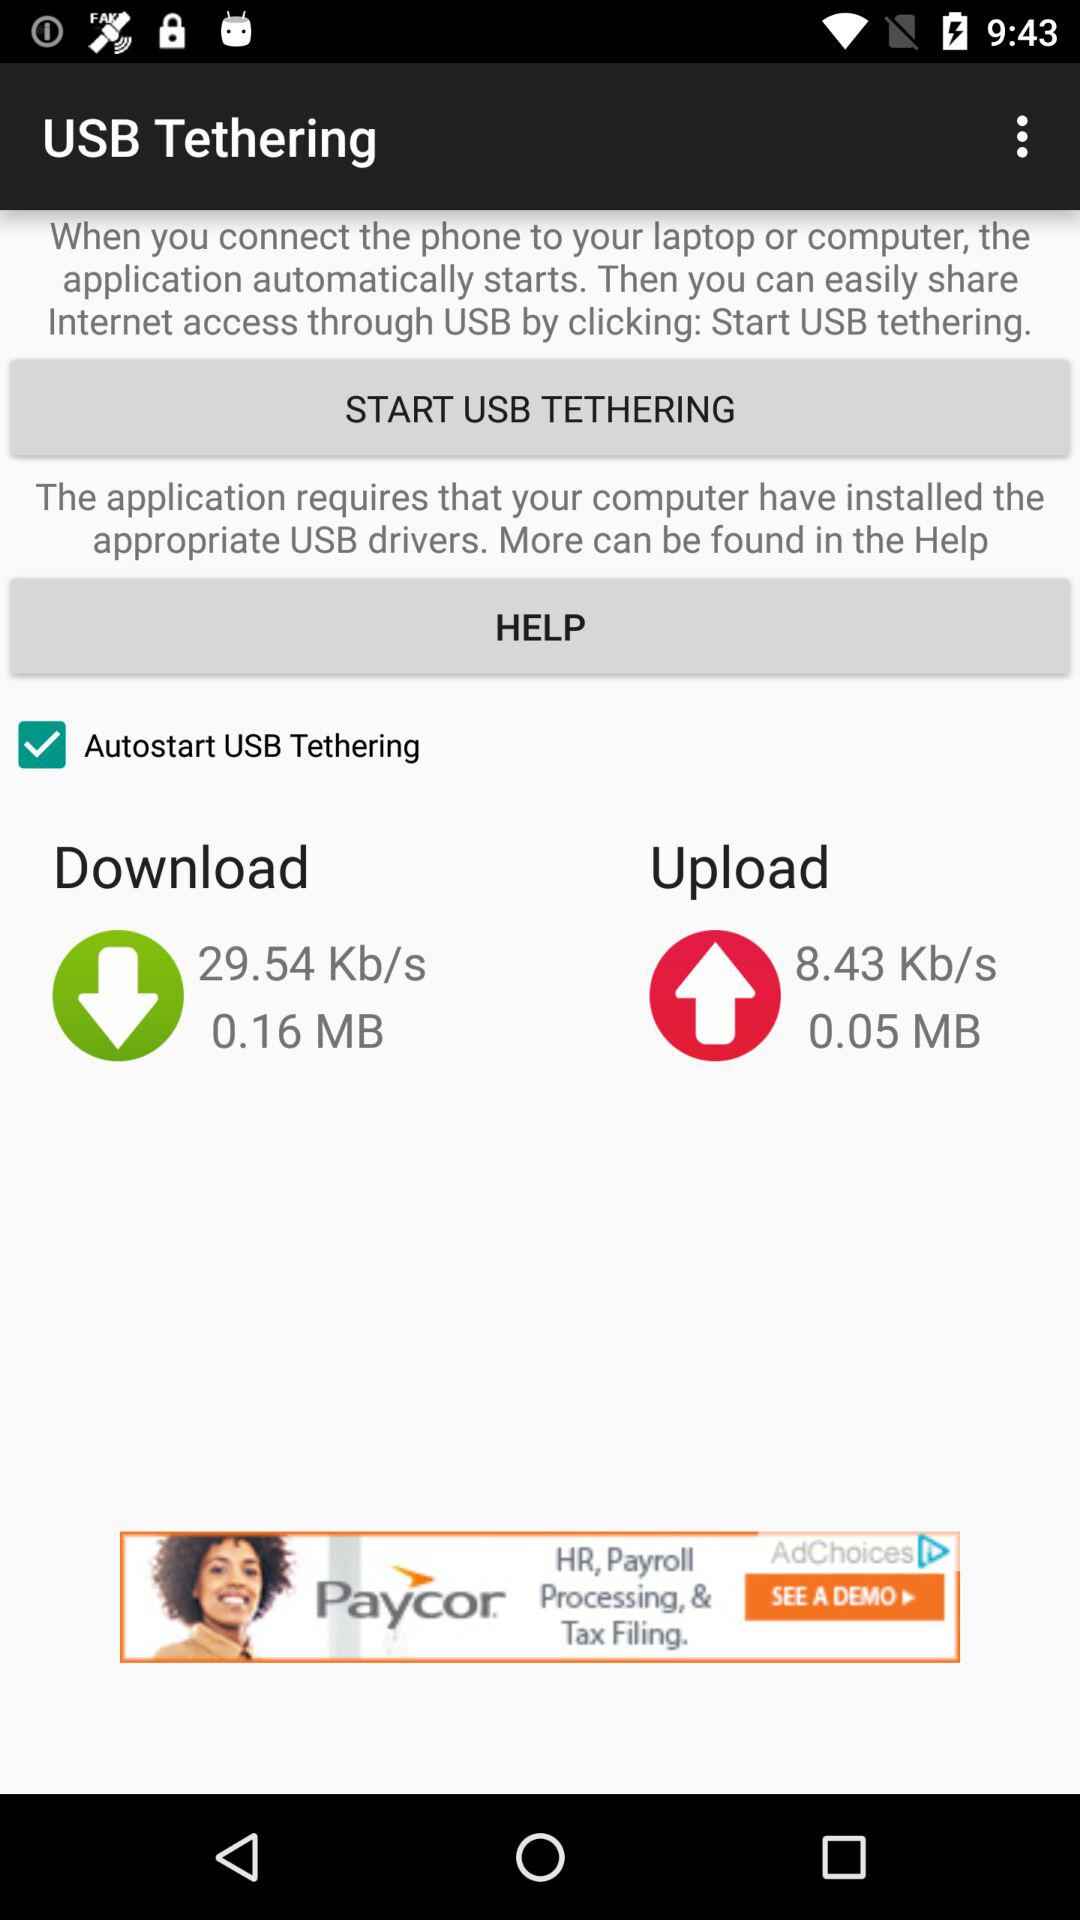How to start USB Tethering?
When the provided information is insufficient, respond with <no answer>. <no answer> 